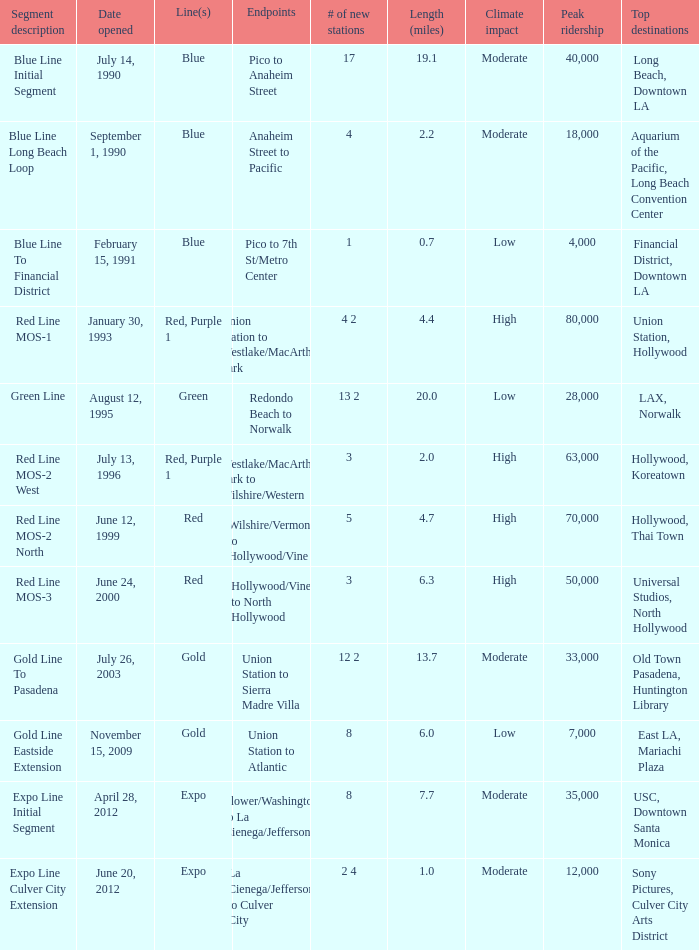How many news stations opened on the date of June 24, 2000? 3.0. 